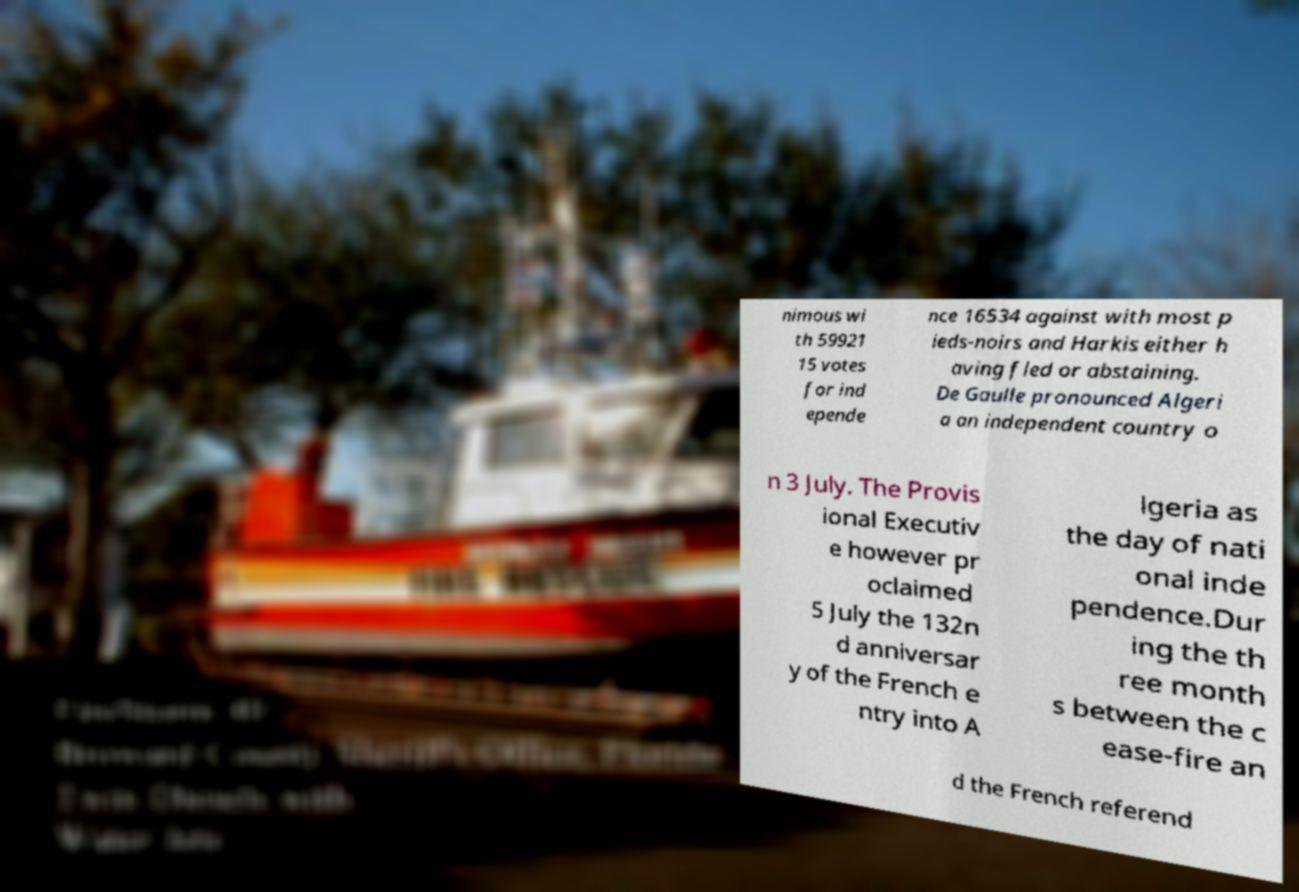Please read and relay the text visible in this image. What does it say? nimous wi th 59921 15 votes for ind epende nce 16534 against with most p ieds-noirs and Harkis either h aving fled or abstaining. De Gaulle pronounced Algeri a an independent country o n 3 July. The Provis ional Executiv e however pr oclaimed 5 July the 132n d anniversar y of the French e ntry into A lgeria as the day of nati onal inde pendence.Dur ing the th ree month s between the c ease-fire an d the French referend 